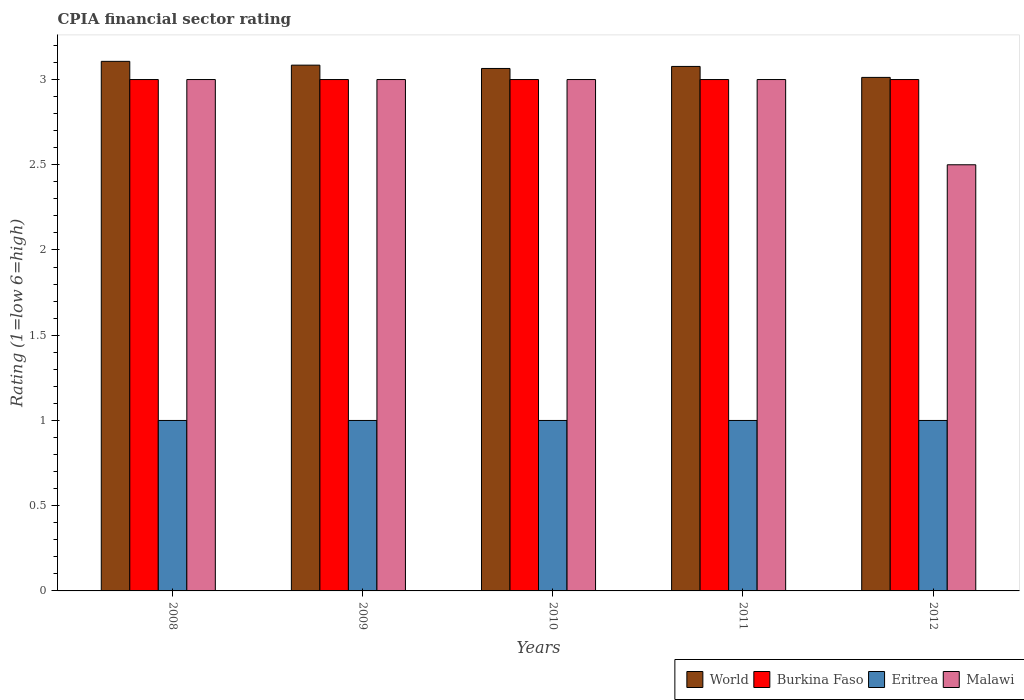How many different coloured bars are there?
Your response must be concise. 4. How many groups of bars are there?
Offer a terse response. 5. In how many cases, is the number of bars for a given year not equal to the number of legend labels?
Keep it short and to the point. 0. What is the CPIA rating in Malawi in 2008?
Make the answer very short. 3. Across all years, what is the maximum CPIA rating in Eritrea?
Offer a very short reply. 1. Across all years, what is the minimum CPIA rating in Burkina Faso?
Offer a very short reply. 3. In which year was the CPIA rating in Eritrea maximum?
Your response must be concise. 2008. What is the total CPIA rating in World in the graph?
Provide a succinct answer. 15.35. What is the difference between the CPIA rating in World in 2011 and the CPIA rating in Burkina Faso in 2009?
Provide a short and direct response. 0.08. What is the average CPIA rating in Malawi per year?
Your answer should be very brief. 2.9. In the year 2008, what is the difference between the CPIA rating in World and CPIA rating in Eritrea?
Offer a terse response. 2.11. What is the ratio of the CPIA rating in Burkina Faso in 2009 to that in 2010?
Offer a terse response. 1. Is the CPIA rating in World in 2008 less than that in 2011?
Give a very brief answer. No. Is the difference between the CPIA rating in World in 2009 and 2011 greater than the difference between the CPIA rating in Eritrea in 2009 and 2011?
Make the answer very short. Yes. What is the difference between the highest and the lowest CPIA rating in Eritrea?
Offer a very short reply. 0. What does the 3rd bar from the left in 2009 represents?
Provide a succinct answer. Eritrea. What does the 3rd bar from the right in 2008 represents?
Provide a short and direct response. Burkina Faso. Is it the case that in every year, the sum of the CPIA rating in Eritrea and CPIA rating in Malawi is greater than the CPIA rating in World?
Make the answer very short. Yes. How many bars are there?
Make the answer very short. 20. How many years are there in the graph?
Give a very brief answer. 5. What is the difference between two consecutive major ticks on the Y-axis?
Give a very brief answer. 0.5. Does the graph contain grids?
Offer a terse response. No. Where does the legend appear in the graph?
Keep it short and to the point. Bottom right. How are the legend labels stacked?
Offer a terse response. Horizontal. What is the title of the graph?
Make the answer very short. CPIA financial sector rating. What is the label or title of the X-axis?
Make the answer very short. Years. What is the label or title of the Y-axis?
Give a very brief answer. Rating (1=low 6=high). What is the Rating (1=low 6=high) in World in 2008?
Your response must be concise. 3.11. What is the Rating (1=low 6=high) of Eritrea in 2008?
Offer a terse response. 1. What is the Rating (1=low 6=high) in Malawi in 2008?
Make the answer very short. 3. What is the Rating (1=low 6=high) of World in 2009?
Your answer should be very brief. 3.08. What is the Rating (1=low 6=high) of Burkina Faso in 2009?
Your answer should be very brief. 3. What is the Rating (1=low 6=high) in Eritrea in 2009?
Your answer should be very brief. 1. What is the Rating (1=low 6=high) in World in 2010?
Offer a very short reply. 3.06. What is the Rating (1=low 6=high) of Burkina Faso in 2010?
Make the answer very short. 3. What is the Rating (1=low 6=high) of Eritrea in 2010?
Your answer should be very brief. 1. What is the Rating (1=low 6=high) of Malawi in 2010?
Offer a very short reply. 3. What is the Rating (1=low 6=high) in World in 2011?
Keep it short and to the point. 3.08. What is the Rating (1=low 6=high) of Malawi in 2011?
Your response must be concise. 3. What is the Rating (1=low 6=high) in World in 2012?
Keep it short and to the point. 3.01. What is the Rating (1=low 6=high) of Malawi in 2012?
Give a very brief answer. 2.5. Across all years, what is the maximum Rating (1=low 6=high) in World?
Provide a short and direct response. 3.11. Across all years, what is the maximum Rating (1=low 6=high) in Burkina Faso?
Offer a very short reply. 3. Across all years, what is the maximum Rating (1=low 6=high) in Eritrea?
Ensure brevity in your answer.  1. Across all years, what is the minimum Rating (1=low 6=high) in World?
Make the answer very short. 3.01. What is the total Rating (1=low 6=high) in World in the graph?
Your answer should be compact. 15.35. What is the total Rating (1=low 6=high) of Burkina Faso in the graph?
Your answer should be very brief. 15. What is the total Rating (1=low 6=high) in Malawi in the graph?
Your answer should be very brief. 14.5. What is the difference between the Rating (1=low 6=high) in World in 2008 and that in 2009?
Offer a very short reply. 0.02. What is the difference between the Rating (1=low 6=high) in Malawi in 2008 and that in 2009?
Make the answer very short. 0. What is the difference between the Rating (1=low 6=high) in World in 2008 and that in 2010?
Your response must be concise. 0.04. What is the difference between the Rating (1=low 6=high) of Burkina Faso in 2008 and that in 2010?
Offer a terse response. 0. What is the difference between the Rating (1=low 6=high) of World in 2008 and that in 2011?
Your answer should be compact. 0.03. What is the difference between the Rating (1=low 6=high) of Burkina Faso in 2008 and that in 2011?
Your response must be concise. 0. What is the difference between the Rating (1=low 6=high) in Eritrea in 2008 and that in 2011?
Provide a short and direct response. 0. What is the difference between the Rating (1=low 6=high) in Malawi in 2008 and that in 2011?
Your response must be concise. 0. What is the difference between the Rating (1=low 6=high) of World in 2008 and that in 2012?
Give a very brief answer. 0.09. What is the difference between the Rating (1=low 6=high) in Burkina Faso in 2008 and that in 2012?
Your answer should be very brief. 0. What is the difference between the Rating (1=low 6=high) of World in 2009 and that in 2010?
Ensure brevity in your answer.  0.02. What is the difference between the Rating (1=low 6=high) in Malawi in 2009 and that in 2010?
Offer a terse response. 0. What is the difference between the Rating (1=low 6=high) in World in 2009 and that in 2011?
Offer a very short reply. 0.01. What is the difference between the Rating (1=low 6=high) in Burkina Faso in 2009 and that in 2011?
Provide a succinct answer. 0. What is the difference between the Rating (1=low 6=high) of World in 2009 and that in 2012?
Your answer should be compact. 0.07. What is the difference between the Rating (1=low 6=high) of Burkina Faso in 2009 and that in 2012?
Offer a terse response. 0. What is the difference between the Rating (1=low 6=high) of World in 2010 and that in 2011?
Provide a short and direct response. -0.01. What is the difference between the Rating (1=low 6=high) in World in 2010 and that in 2012?
Make the answer very short. 0.05. What is the difference between the Rating (1=low 6=high) in Malawi in 2010 and that in 2012?
Provide a succinct answer. 0.5. What is the difference between the Rating (1=low 6=high) in World in 2011 and that in 2012?
Ensure brevity in your answer.  0.06. What is the difference between the Rating (1=low 6=high) in Burkina Faso in 2011 and that in 2012?
Keep it short and to the point. 0. What is the difference between the Rating (1=low 6=high) of Malawi in 2011 and that in 2012?
Your answer should be compact. 0.5. What is the difference between the Rating (1=low 6=high) in World in 2008 and the Rating (1=low 6=high) in Burkina Faso in 2009?
Keep it short and to the point. 0.11. What is the difference between the Rating (1=low 6=high) of World in 2008 and the Rating (1=low 6=high) of Eritrea in 2009?
Offer a terse response. 2.11. What is the difference between the Rating (1=low 6=high) in World in 2008 and the Rating (1=low 6=high) in Malawi in 2009?
Your response must be concise. 0.11. What is the difference between the Rating (1=low 6=high) of Burkina Faso in 2008 and the Rating (1=low 6=high) of Malawi in 2009?
Make the answer very short. 0. What is the difference between the Rating (1=low 6=high) in Eritrea in 2008 and the Rating (1=low 6=high) in Malawi in 2009?
Make the answer very short. -2. What is the difference between the Rating (1=low 6=high) of World in 2008 and the Rating (1=low 6=high) of Burkina Faso in 2010?
Ensure brevity in your answer.  0.11. What is the difference between the Rating (1=low 6=high) of World in 2008 and the Rating (1=low 6=high) of Eritrea in 2010?
Your answer should be compact. 2.11. What is the difference between the Rating (1=low 6=high) in World in 2008 and the Rating (1=low 6=high) in Malawi in 2010?
Ensure brevity in your answer.  0.11. What is the difference between the Rating (1=low 6=high) in Burkina Faso in 2008 and the Rating (1=low 6=high) in Eritrea in 2010?
Provide a short and direct response. 2. What is the difference between the Rating (1=low 6=high) in World in 2008 and the Rating (1=low 6=high) in Burkina Faso in 2011?
Keep it short and to the point. 0.11. What is the difference between the Rating (1=low 6=high) in World in 2008 and the Rating (1=low 6=high) in Eritrea in 2011?
Your answer should be compact. 2.11. What is the difference between the Rating (1=low 6=high) in World in 2008 and the Rating (1=low 6=high) in Malawi in 2011?
Your response must be concise. 0.11. What is the difference between the Rating (1=low 6=high) of Burkina Faso in 2008 and the Rating (1=low 6=high) of Eritrea in 2011?
Offer a terse response. 2. What is the difference between the Rating (1=low 6=high) of World in 2008 and the Rating (1=low 6=high) of Burkina Faso in 2012?
Your answer should be compact. 0.11. What is the difference between the Rating (1=low 6=high) of World in 2008 and the Rating (1=low 6=high) of Eritrea in 2012?
Your response must be concise. 2.11. What is the difference between the Rating (1=low 6=high) of World in 2008 and the Rating (1=low 6=high) of Malawi in 2012?
Give a very brief answer. 0.61. What is the difference between the Rating (1=low 6=high) in Eritrea in 2008 and the Rating (1=low 6=high) in Malawi in 2012?
Keep it short and to the point. -1.5. What is the difference between the Rating (1=low 6=high) in World in 2009 and the Rating (1=low 6=high) in Burkina Faso in 2010?
Your answer should be very brief. 0.08. What is the difference between the Rating (1=low 6=high) in World in 2009 and the Rating (1=low 6=high) in Eritrea in 2010?
Offer a very short reply. 2.08. What is the difference between the Rating (1=low 6=high) of World in 2009 and the Rating (1=low 6=high) of Malawi in 2010?
Make the answer very short. 0.08. What is the difference between the Rating (1=low 6=high) of Burkina Faso in 2009 and the Rating (1=low 6=high) of Eritrea in 2010?
Make the answer very short. 2. What is the difference between the Rating (1=low 6=high) of Burkina Faso in 2009 and the Rating (1=low 6=high) of Malawi in 2010?
Make the answer very short. 0. What is the difference between the Rating (1=low 6=high) of World in 2009 and the Rating (1=low 6=high) of Burkina Faso in 2011?
Ensure brevity in your answer.  0.08. What is the difference between the Rating (1=low 6=high) of World in 2009 and the Rating (1=low 6=high) of Eritrea in 2011?
Your answer should be very brief. 2.08. What is the difference between the Rating (1=low 6=high) of World in 2009 and the Rating (1=low 6=high) of Malawi in 2011?
Your answer should be compact. 0.08. What is the difference between the Rating (1=low 6=high) in World in 2009 and the Rating (1=low 6=high) in Burkina Faso in 2012?
Provide a short and direct response. 0.08. What is the difference between the Rating (1=low 6=high) of World in 2009 and the Rating (1=low 6=high) of Eritrea in 2012?
Keep it short and to the point. 2.08. What is the difference between the Rating (1=low 6=high) in World in 2009 and the Rating (1=low 6=high) in Malawi in 2012?
Provide a short and direct response. 0.58. What is the difference between the Rating (1=low 6=high) in Burkina Faso in 2009 and the Rating (1=low 6=high) in Eritrea in 2012?
Provide a short and direct response. 2. What is the difference between the Rating (1=low 6=high) of Burkina Faso in 2009 and the Rating (1=low 6=high) of Malawi in 2012?
Offer a terse response. 0.5. What is the difference between the Rating (1=low 6=high) of Eritrea in 2009 and the Rating (1=low 6=high) of Malawi in 2012?
Your answer should be compact. -1.5. What is the difference between the Rating (1=low 6=high) in World in 2010 and the Rating (1=low 6=high) in Burkina Faso in 2011?
Your answer should be compact. 0.06. What is the difference between the Rating (1=low 6=high) of World in 2010 and the Rating (1=low 6=high) of Eritrea in 2011?
Ensure brevity in your answer.  2.06. What is the difference between the Rating (1=low 6=high) of World in 2010 and the Rating (1=low 6=high) of Malawi in 2011?
Ensure brevity in your answer.  0.06. What is the difference between the Rating (1=low 6=high) in Burkina Faso in 2010 and the Rating (1=low 6=high) in Eritrea in 2011?
Offer a terse response. 2. What is the difference between the Rating (1=low 6=high) in World in 2010 and the Rating (1=low 6=high) in Burkina Faso in 2012?
Provide a succinct answer. 0.06. What is the difference between the Rating (1=low 6=high) in World in 2010 and the Rating (1=low 6=high) in Eritrea in 2012?
Offer a terse response. 2.06. What is the difference between the Rating (1=low 6=high) of World in 2010 and the Rating (1=low 6=high) of Malawi in 2012?
Your answer should be very brief. 0.56. What is the difference between the Rating (1=low 6=high) of Burkina Faso in 2010 and the Rating (1=low 6=high) of Eritrea in 2012?
Your answer should be very brief. 2. What is the difference between the Rating (1=low 6=high) of World in 2011 and the Rating (1=low 6=high) of Burkina Faso in 2012?
Keep it short and to the point. 0.08. What is the difference between the Rating (1=low 6=high) in World in 2011 and the Rating (1=low 6=high) in Eritrea in 2012?
Offer a terse response. 2.08. What is the difference between the Rating (1=low 6=high) of World in 2011 and the Rating (1=low 6=high) of Malawi in 2012?
Your response must be concise. 0.58. What is the difference between the Rating (1=low 6=high) in Burkina Faso in 2011 and the Rating (1=low 6=high) in Eritrea in 2012?
Your answer should be very brief. 2. What is the difference between the Rating (1=low 6=high) of Burkina Faso in 2011 and the Rating (1=low 6=high) of Malawi in 2012?
Provide a succinct answer. 0.5. What is the difference between the Rating (1=low 6=high) of Eritrea in 2011 and the Rating (1=low 6=high) of Malawi in 2012?
Your answer should be very brief. -1.5. What is the average Rating (1=low 6=high) in World per year?
Offer a terse response. 3.07. What is the average Rating (1=low 6=high) in Burkina Faso per year?
Provide a short and direct response. 3. What is the average Rating (1=low 6=high) in Malawi per year?
Give a very brief answer. 2.9. In the year 2008, what is the difference between the Rating (1=low 6=high) in World and Rating (1=low 6=high) in Burkina Faso?
Give a very brief answer. 0.11. In the year 2008, what is the difference between the Rating (1=low 6=high) of World and Rating (1=low 6=high) of Eritrea?
Your answer should be compact. 2.11. In the year 2008, what is the difference between the Rating (1=low 6=high) of World and Rating (1=low 6=high) of Malawi?
Your response must be concise. 0.11. In the year 2008, what is the difference between the Rating (1=low 6=high) in Burkina Faso and Rating (1=low 6=high) in Eritrea?
Your answer should be compact. 2. In the year 2008, what is the difference between the Rating (1=low 6=high) of Burkina Faso and Rating (1=low 6=high) of Malawi?
Your answer should be very brief. 0. In the year 2008, what is the difference between the Rating (1=low 6=high) of Eritrea and Rating (1=low 6=high) of Malawi?
Your response must be concise. -2. In the year 2009, what is the difference between the Rating (1=low 6=high) in World and Rating (1=low 6=high) in Burkina Faso?
Your response must be concise. 0.08. In the year 2009, what is the difference between the Rating (1=low 6=high) of World and Rating (1=low 6=high) of Eritrea?
Make the answer very short. 2.08. In the year 2009, what is the difference between the Rating (1=low 6=high) in World and Rating (1=low 6=high) in Malawi?
Keep it short and to the point. 0.08. In the year 2009, what is the difference between the Rating (1=low 6=high) in Burkina Faso and Rating (1=low 6=high) in Malawi?
Make the answer very short. 0. In the year 2010, what is the difference between the Rating (1=low 6=high) in World and Rating (1=low 6=high) in Burkina Faso?
Your response must be concise. 0.06. In the year 2010, what is the difference between the Rating (1=low 6=high) of World and Rating (1=low 6=high) of Eritrea?
Keep it short and to the point. 2.06. In the year 2010, what is the difference between the Rating (1=low 6=high) in World and Rating (1=low 6=high) in Malawi?
Your answer should be compact. 0.06. In the year 2010, what is the difference between the Rating (1=low 6=high) in Burkina Faso and Rating (1=low 6=high) in Malawi?
Keep it short and to the point. 0. In the year 2011, what is the difference between the Rating (1=low 6=high) in World and Rating (1=low 6=high) in Burkina Faso?
Make the answer very short. 0.08. In the year 2011, what is the difference between the Rating (1=low 6=high) of World and Rating (1=low 6=high) of Eritrea?
Give a very brief answer. 2.08. In the year 2011, what is the difference between the Rating (1=low 6=high) of World and Rating (1=low 6=high) of Malawi?
Ensure brevity in your answer.  0.08. In the year 2011, what is the difference between the Rating (1=low 6=high) of Burkina Faso and Rating (1=low 6=high) of Eritrea?
Make the answer very short. 2. In the year 2011, what is the difference between the Rating (1=low 6=high) in Eritrea and Rating (1=low 6=high) in Malawi?
Your answer should be compact. -2. In the year 2012, what is the difference between the Rating (1=low 6=high) of World and Rating (1=low 6=high) of Burkina Faso?
Your answer should be compact. 0.01. In the year 2012, what is the difference between the Rating (1=low 6=high) in World and Rating (1=low 6=high) in Eritrea?
Provide a succinct answer. 2.01. In the year 2012, what is the difference between the Rating (1=low 6=high) of World and Rating (1=low 6=high) of Malawi?
Make the answer very short. 0.51. In the year 2012, what is the difference between the Rating (1=low 6=high) of Burkina Faso and Rating (1=low 6=high) of Eritrea?
Provide a short and direct response. 2. In the year 2012, what is the difference between the Rating (1=low 6=high) in Burkina Faso and Rating (1=low 6=high) in Malawi?
Offer a terse response. 0.5. In the year 2012, what is the difference between the Rating (1=low 6=high) in Eritrea and Rating (1=low 6=high) in Malawi?
Provide a succinct answer. -1.5. What is the ratio of the Rating (1=low 6=high) of Burkina Faso in 2008 to that in 2009?
Your answer should be compact. 1. What is the ratio of the Rating (1=low 6=high) in Malawi in 2008 to that in 2009?
Your answer should be compact. 1. What is the ratio of the Rating (1=low 6=high) of World in 2008 to that in 2010?
Ensure brevity in your answer.  1.01. What is the ratio of the Rating (1=low 6=high) of Burkina Faso in 2008 to that in 2010?
Provide a succinct answer. 1. What is the ratio of the Rating (1=low 6=high) in Eritrea in 2008 to that in 2010?
Give a very brief answer. 1. What is the ratio of the Rating (1=low 6=high) of World in 2008 to that in 2011?
Make the answer very short. 1.01. What is the ratio of the Rating (1=low 6=high) of Eritrea in 2008 to that in 2011?
Keep it short and to the point. 1. What is the ratio of the Rating (1=low 6=high) of Malawi in 2008 to that in 2011?
Your response must be concise. 1. What is the ratio of the Rating (1=low 6=high) in World in 2008 to that in 2012?
Your answer should be compact. 1.03. What is the ratio of the Rating (1=low 6=high) in Burkina Faso in 2008 to that in 2012?
Ensure brevity in your answer.  1. What is the ratio of the Rating (1=low 6=high) in Eritrea in 2008 to that in 2012?
Provide a short and direct response. 1. What is the ratio of the Rating (1=low 6=high) in World in 2009 to that in 2010?
Provide a succinct answer. 1.01. What is the ratio of the Rating (1=low 6=high) in Burkina Faso in 2009 to that in 2010?
Provide a short and direct response. 1. What is the ratio of the Rating (1=low 6=high) in Eritrea in 2009 to that in 2010?
Your answer should be very brief. 1. What is the ratio of the Rating (1=low 6=high) in Malawi in 2009 to that in 2010?
Your answer should be compact. 1. What is the ratio of the Rating (1=low 6=high) in Burkina Faso in 2009 to that in 2011?
Make the answer very short. 1. What is the ratio of the Rating (1=low 6=high) of Eritrea in 2009 to that in 2011?
Give a very brief answer. 1. What is the ratio of the Rating (1=low 6=high) in World in 2009 to that in 2012?
Keep it short and to the point. 1.02. What is the ratio of the Rating (1=low 6=high) of Burkina Faso in 2009 to that in 2012?
Your answer should be compact. 1. What is the ratio of the Rating (1=low 6=high) in Malawi in 2009 to that in 2012?
Make the answer very short. 1.2. What is the ratio of the Rating (1=low 6=high) of Malawi in 2010 to that in 2011?
Your answer should be compact. 1. What is the ratio of the Rating (1=low 6=high) of World in 2010 to that in 2012?
Provide a short and direct response. 1.02. What is the ratio of the Rating (1=low 6=high) of World in 2011 to that in 2012?
Your answer should be compact. 1.02. What is the ratio of the Rating (1=low 6=high) of Burkina Faso in 2011 to that in 2012?
Your answer should be compact. 1. What is the ratio of the Rating (1=low 6=high) of Eritrea in 2011 to that in 2012?
Offer a very short reply. 1. What is the ratio of the Rating (1=low 6=high) in Malawi in 2011 to that in 2012?
Provide a succinct answer. 1.2. What is the difference between the highest and the second highest Rating (1=low 6=high) of World?
Provide a short and direct response. 0.02. What is the difference between the highest and the second highest Rating (1=low 6=high) of Malawi?
Give a very brief answer. 0. What is the difference between the highest and the lowest Rating (1=low 6=high) in World?
Offer a terse response. 0.09. What is the difference between the highest and the lowest Rating (1=low 6=high) of Burkina Faso?
Your answer should be compact. 0. What is the difference between the highest and the lowest Rating (1=low 6=high) of Eritrea?
Offer a terse response. 0. What is the difference between the highest and the lowest Rating (1=low 6=high) of Malawi?
Give a very brief answer. 0.5. 